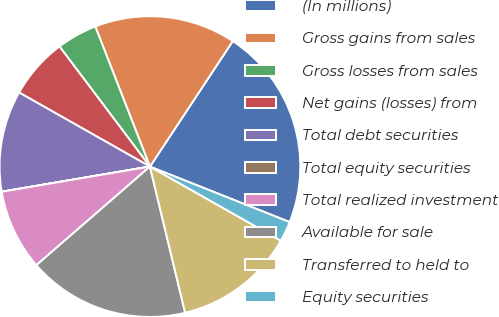Convert chart to OTSL. <chart><loc_0><loc_0><loc_500><loc_500><pie_chart><fcel>(In millions)<fcel>Gross gains from sales<fcel>Gross losses from sales<fcel>Net gains (losses) from<fcel>Total debt securities<fcel>Total equity securities<fcel>Total realized investment<fcel>Available for sale<fcel>Transferred to held to<fcel>Equity securities<nl><fcel>21.73%<fcel>15.21%<fcel>4.35%<fcel>6.53%<fcel>10.87%<fcel>0.01%<fcel>8.7%<fcel>17.38%<fcel>13.04%<fcel>2.18%<nl></chart> 